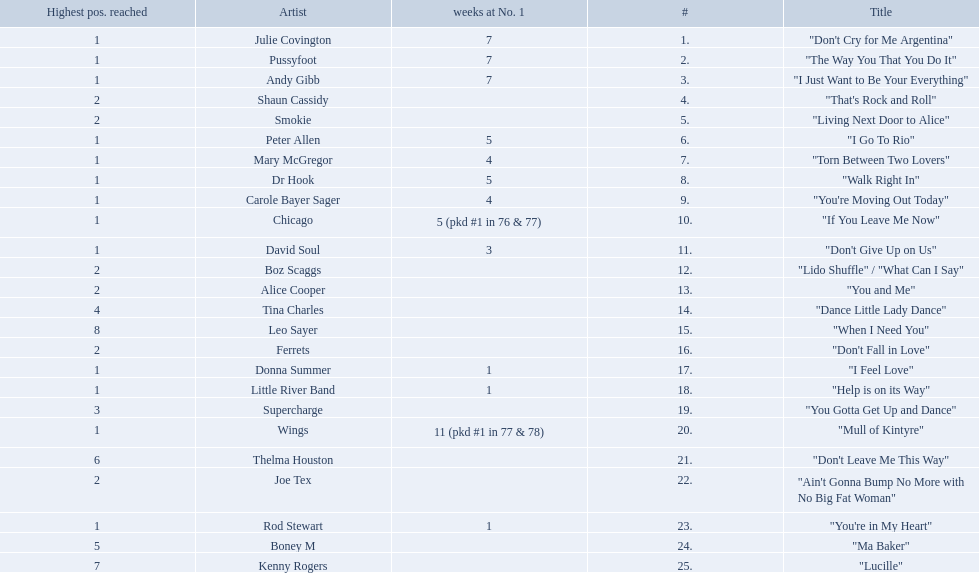Which artists were included in the top 25 singles for 1977 in australia? Julie Covington, Pussyfoot, Andy Gibb, Shaun Cassidy, Smokie, Peter Allen, Mary McGregor, Dr Hook, Carole Bayer Sager, Chicago, David Soul, Boz Scaggs, Alice Cooper, Tina Charles, Leo Sayer, Ferrets, Donna Summer, Little River Band, Supercharge, Wings, Thelma Houston, Joe Tex, Rod Stewart, Boney M, Kenny Rogers. And for how many weeks did they chart at number 1? 7, 7, 7, , , 5, 4, 5, 4, 5 (pkd #1 in 76 & 77), 3, , , , , , 1, 1, , 11 (pkd #1 in 77 & 78), , , 1, , . Which artist was in the number 1 spot for most time? Wings. 